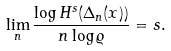<formula> <loc_0><loc_0><loc_500><loc_500>\lim _ { n } \frac { \log H ^ { s } ( \Delta _ { n } ( x ) ) } { n \log \varrho } = s .</formula> 